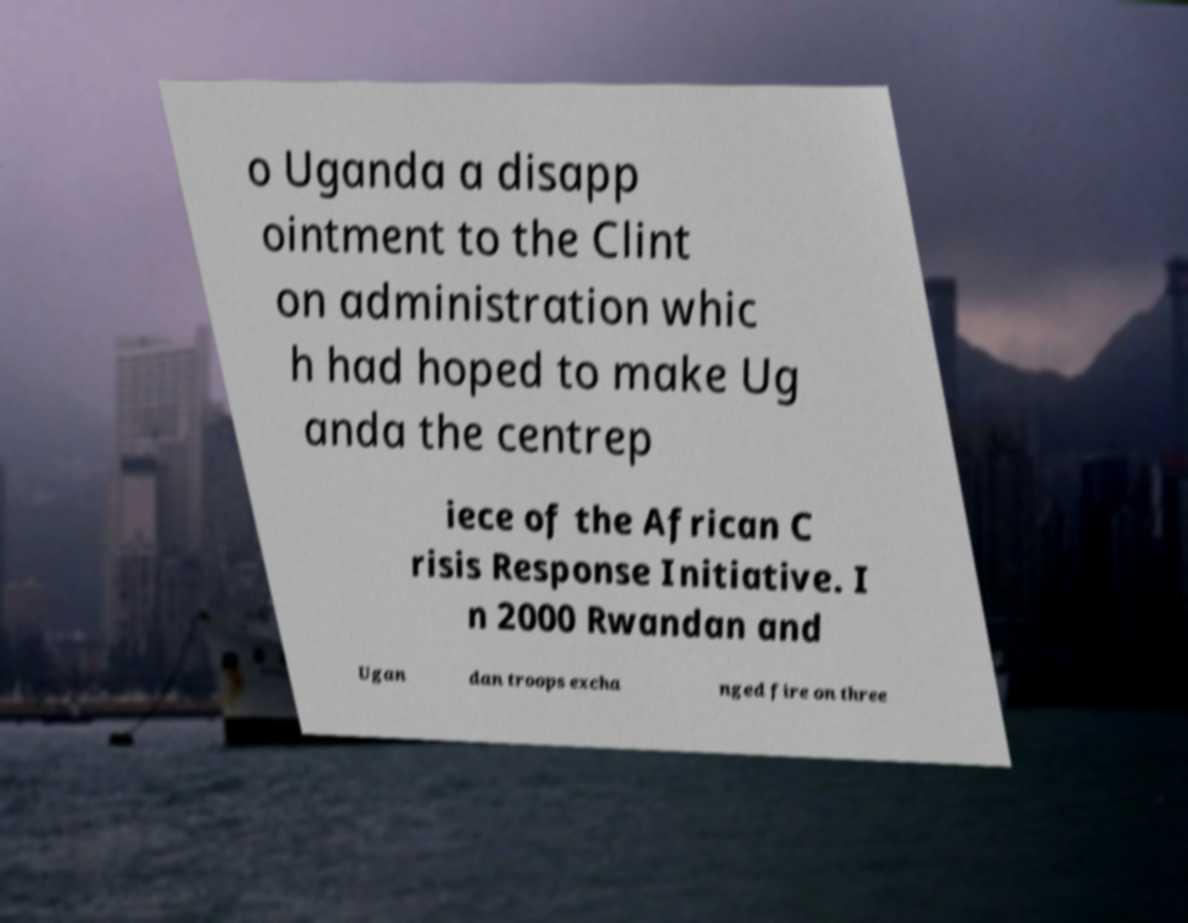Please read and relay the text visible in this image. What does it say? o Uganda a disapp ointment to the Clint on administration whic h had hoped to make Ug anda the centrep iece of the African C risis Response Initiative. I n 2000 Rwandan and Ugan dan troops excha nged fire on three 